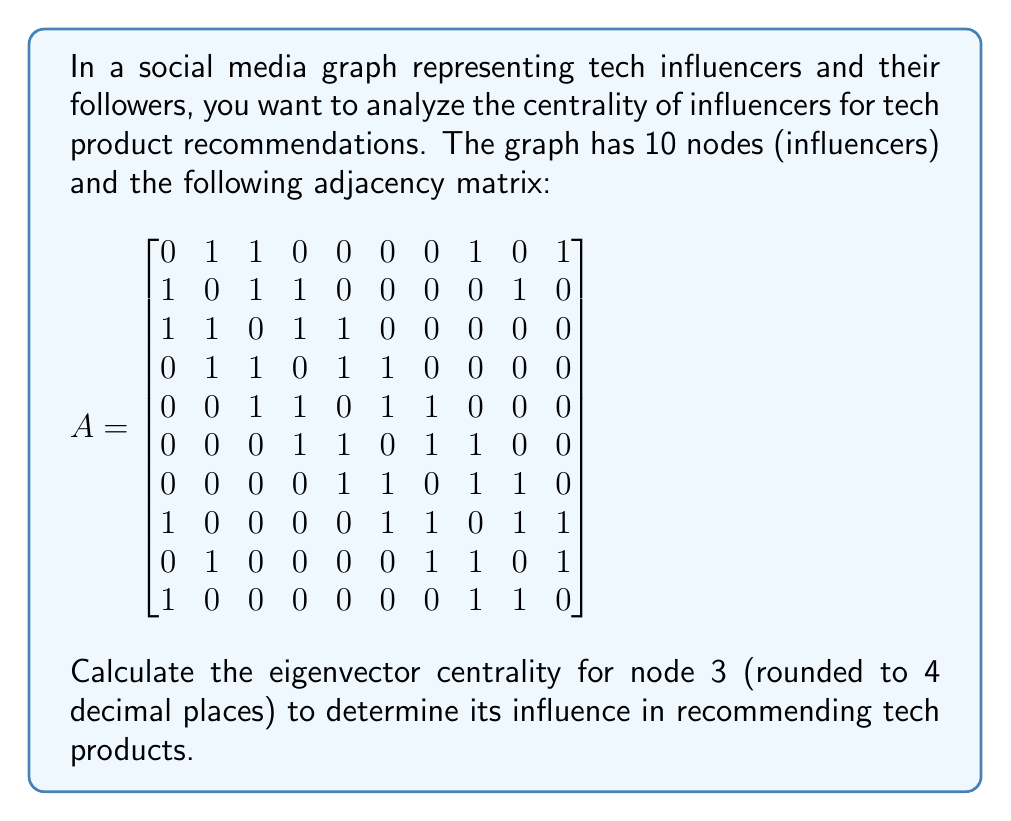Help me with this question. To calculate the eigenvector centrality for node 3, we need to follow these steps:

1. Find the largest eigenvalue (λ) and its corresponding eigenvector for the adjacency matrix A.

2. The eigenvector centrality of each node is proportional to the corresponding component of the eigenvector.

Using a mathematical software or numerical methods, we can calculate the largest eigenvalue and its corresponding eigenvector:

Largest eigenvalue: λ ≈ 3.2984

Corresponding eigenvector:
$$
v ≈ \begin{bmatrix}
0.2887 \\
0.3249 \\
0.3749 \\
0.3564 \\
0.3166 \\
0.2887 \\
0.2652 \\
0.3249 \\
0.2652 \\
0.2887
\end{bmatrix}
$$

The eigenvector centrality for each node is obtained by normalizing this eigenvector so that the sum of squares equals 1. This is already the case for the given eigenvector.

The eigenvector centrality for node 3 is the third component of this normalized eigenvector: 0.3749.

Rounding to 4 decimal places, we get 0.3749.

This value indicates that node 3 has relatively high centrality in the network, suggesting it has significant influence in recommending tech products compared to other nodes in the graph.
Answer: 0.3749 